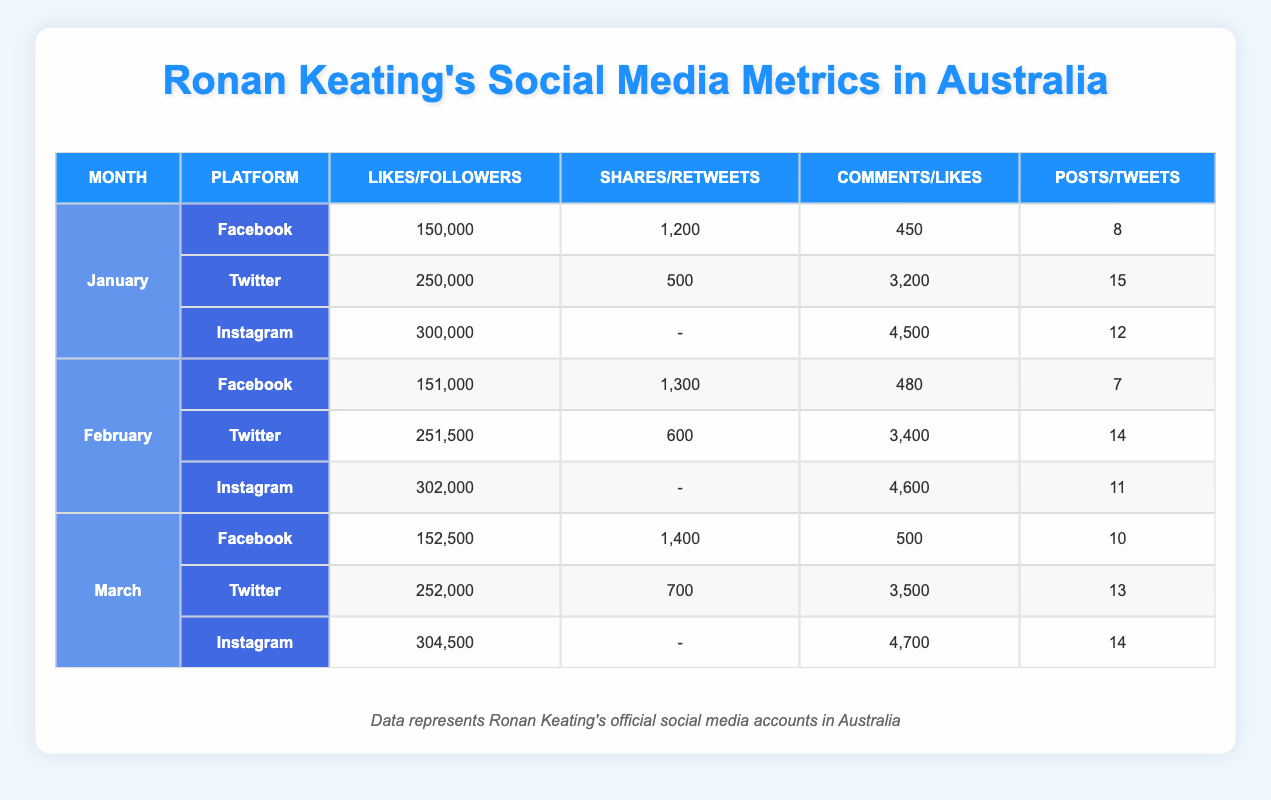What were the total Facebook Likes for Ronan Keating in January? In January, the Facebook Likes for Ronan Keating were listed as 150,000 according to the table.
Answer: 150,000 Which platform had the highest number of Followers in March? In March, the Followers on Twitter were 252,000, while Instagram had 304,500 Followers. Comparing the values, Instagram had the highest number of Followers.
Answer: Instagram How many total Likes did Ronan Keating receive on Instagram for January to March? To find the total Likes on Instagram from January to March, I will sum the Likes: January has 4,500, February has 4,600, and March has 4,700. The total is 4,500 + 4,600 + 4,700 = 13,800.
Answer: 13,800 Did Ronan Keating receive more Shares or Retweets in February? In February, Ronan Keating received 1,300 Shares on Facebook and 600 Retweets on Twitter. Since 1,300 is greater than 600, he received more Shares.
Answer: Yes What is the trend of Facebook Likes from January to March? The Facebook Likes were 150,000 in January, 151,000 in February, and increased to 152,500 in March. The values are rising, indicating a positive trend.
Answer: Rising What was the average number of Posts across all platforms in January? For January, the Posts on Facebook were 8, Twitter had 15 Tweets (which we consider as Posts for this calculation), and Instagram had 12 Posts. To find the average, I will add these values: 8 + 15 + 12 = 35. Then, divide by the number of platforms (3): 35 / 3 = 11.67.
Answer: 11.67 